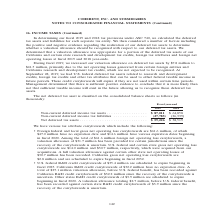According to Coherent's financial document, What was the Net deferred tax assets in 2019? According to the financial document, $59,226 (in thousands). The relevant text states: "s . (27,785) (26,339) Net deferred tax assets . $ 59,226 $ 38,519..." Also, What was the  Non-current deferred income tax assets  in 2018? According to the financial document, $64,858 (in thousands). The relevant text states: "n-current deferred income tax assets . $ 87,011 $ 64,858 Non-current deferred income tax liabilities . (27,785) (26,339) Net deferred tax assets . $ 59,226..." Also, In which years were Net deferred tax assets calculated? The document shows two values: 2019 and 2018. From the document: "In determining our fiscal 2019 and 2018 tax provisions under ASC 740, we calculated the deferred tax assets and liabilities for ea In determining our ..." Additionally, In which year was the amount of Net deferred tax assets larger? According to the financial document, 2019. The relevant text states: "In determining our fiscal 2019 and 2018 tax provisions under ASC 740, we calculated the deferred tax assets and liabilities for ea..." Also, can you calculate: What was the change in Net deferred tax assets from 2018 to 2019? Based on the calculation: 59,226-38,519, the result is 20707 (in thousands). This is based on the information: "85) (26,339) Net deferred tax assets . $ 59,226 $ 38,519 s . (27,785) (26,339) Net deferred tax assets . $ 59,226 $ 38,519..." The key data points involved are: 38,519, 59,226. Also, can you calculate: What was the percentage change in Net deferred tax assets from 2018 to 2019? To answer this question, I need to perform calculations using the financial data. The calculation is: (59,226-38,519)/38,519, which equals 53.76 (percentage). This is based on the information: "85) (26,339) Net deferred tax assets . $ 59,226 $ 38,519 s . (27,785) (26,339) Net deferred tax assets . $ 59,226 $ 38,519..." The key data points involved are: 38,519, 59,226. 